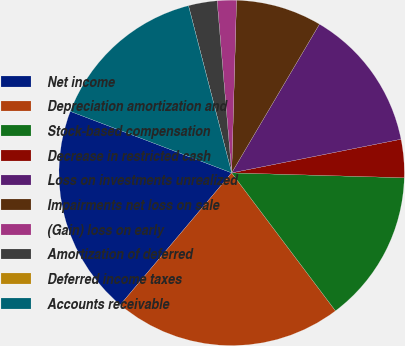Convert chart. <chart><loc_0><loc_0><loc_500><loc_500><pie_chart><fcel>Net income<fcel>Depreciation amortization and<fcel>Stock-based compensation<fcel>Decrease in restricted cash<fcel>Loss on investments unrealized<fcel>Impairments net loss on sale<fcel>(Gain) loss on early<fcel>Amortization of deferred<fcel>Deferred income taxes<fcel>Accounts receivable<nl><fcel>19.64%<fcel>21.42%<fcel>14.28%<fcel>3.57%<fcel>13.39%<fcel>8.04%<fcel>1.79%<fcel>2.68%<fcel>0.0%<fcel>15.18%<nl></chart> 